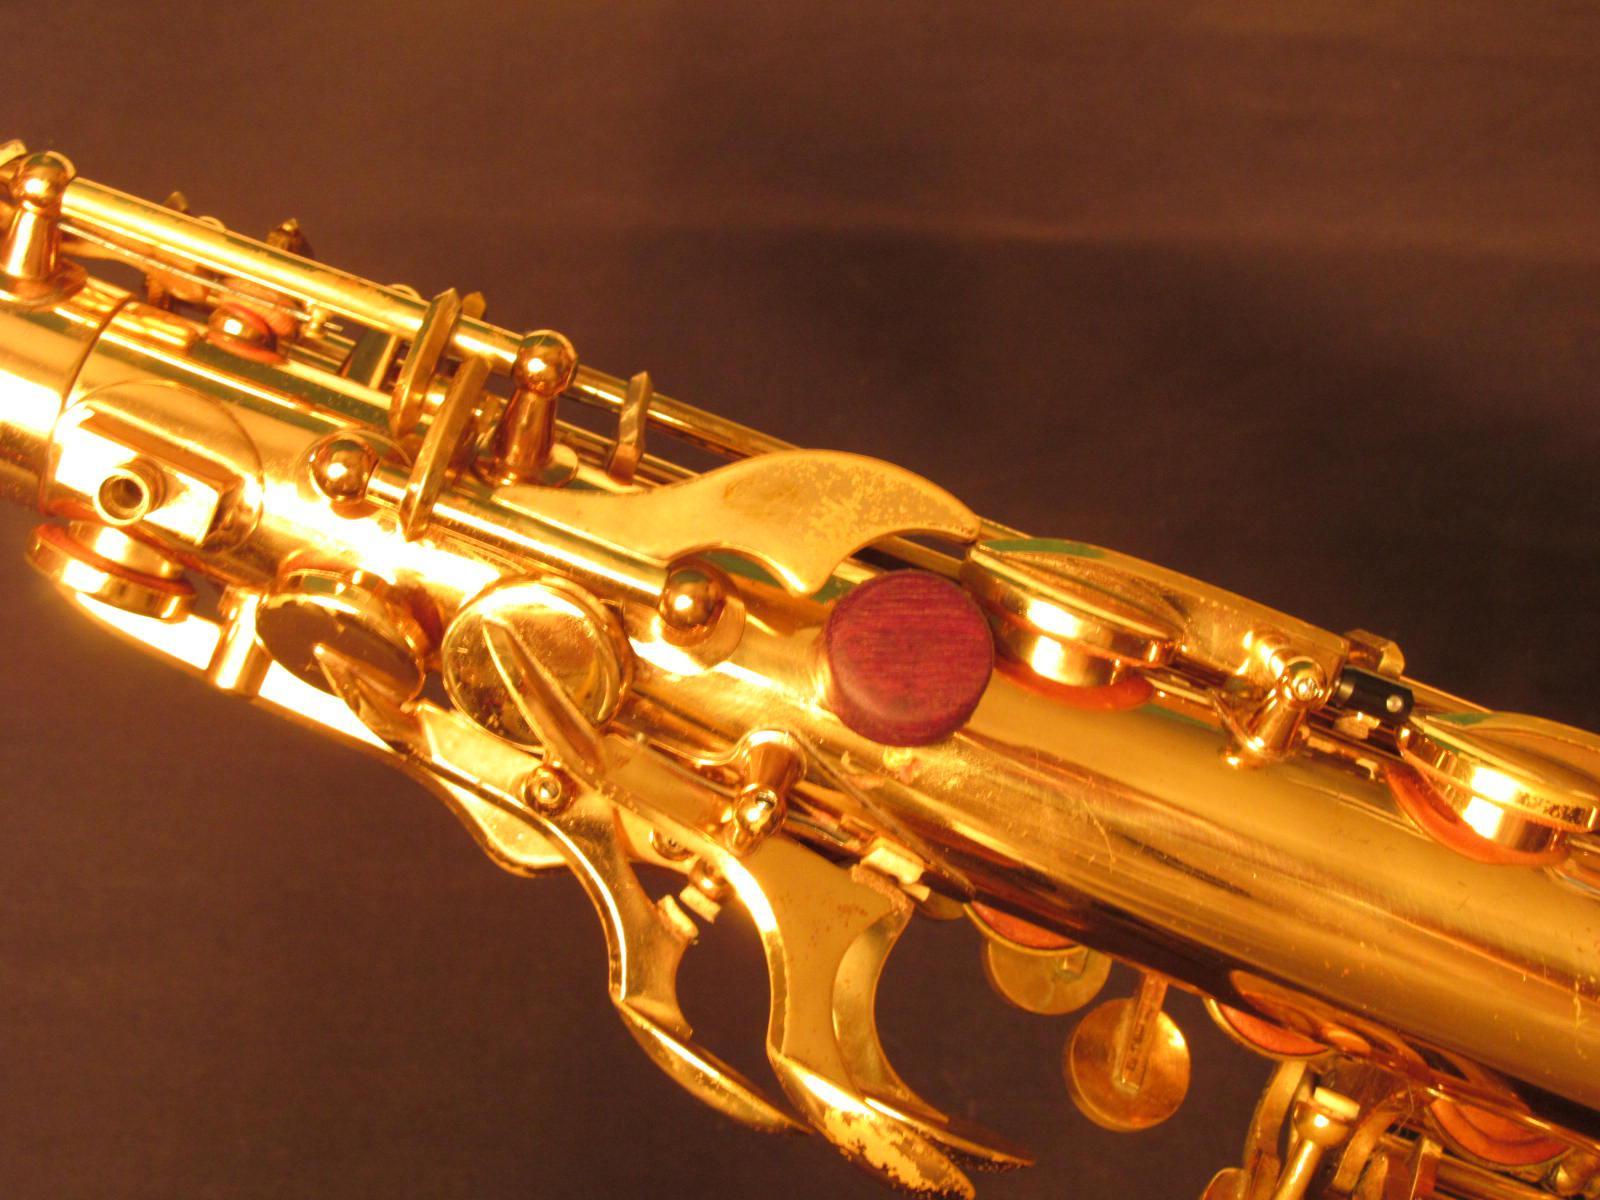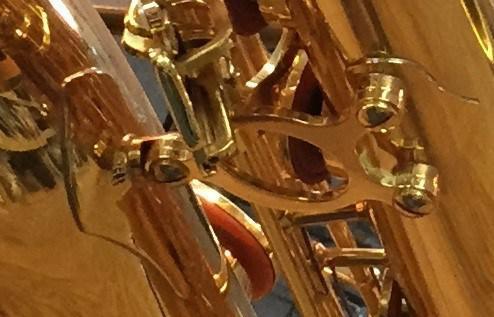The first image is the image on the left, the second image is the image on the right. For the images displayed, is the sentence "An image shows an instrument laying flat on a woodgrain surface." factually correct? Answer yes or no. No. The first image is the image on the left, the second image is the image on the right. Considering the images on both sides, is "One of the images shows the bell of a saxophone but not the mouth piece." valid? Answer yes or no. No. 